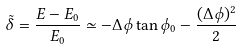<formula> <loc_0><loc_0><loc_500><loc_500>\tilde { \delta } = \frac { E - E _ { 0 } } { E _ { 0 } } \simeq - \Delta \phi \tan \phi _ { 0 } - \frac { ( \Delta \phi ) ^ { 2 } } { 2 }</formula> 